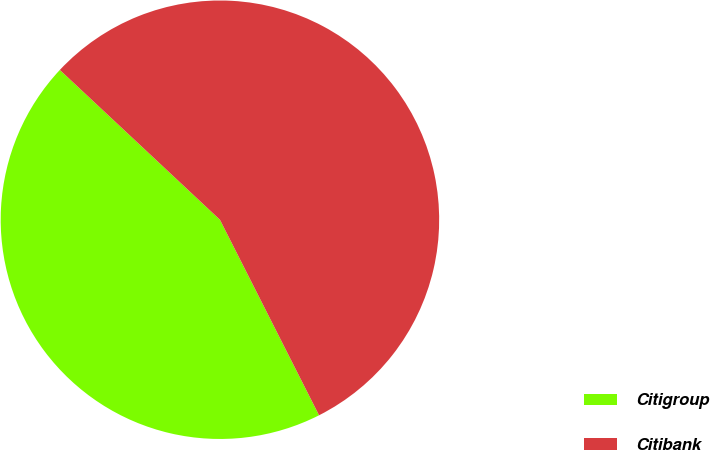Convert chart to OTSL. <chart><loc_0><loc_0><loc_500><loc_500><pie_chart><fcel>Citigroup<fcel>Citibank<nl><fcel>44.44%<fcel>55.56%<nl></chart> 